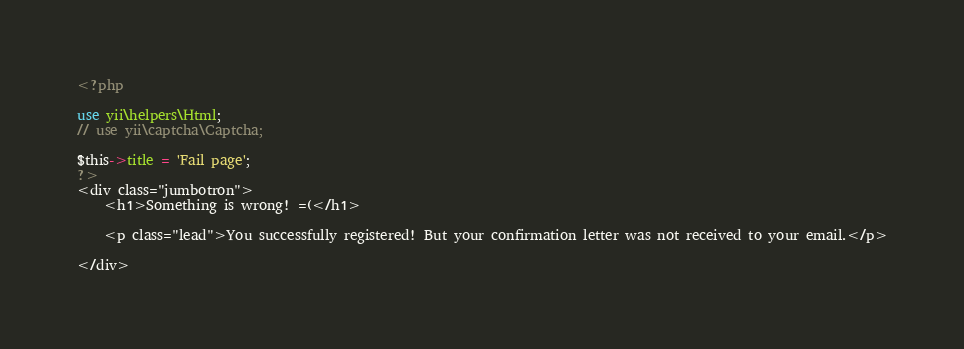Convert code to text. <code><loc_0><loc_0><loc_500><loc_500><_PHP_><?php
 
use yii\helpers\Html;
// use yii\captcha\Captcha;

$this->title = 'Fail page';
?>
<div class="jumbotron">
    <h1>Something is wrong! =(</h1>

    <p class="lead">You successfully registered! But your confirmation letter was not received to your email.</p>

</div></code> 